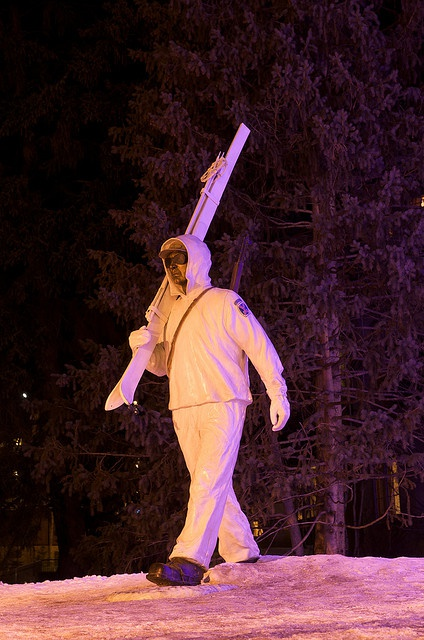Describe the objects in this image and their specific colors. I can see people in black, salmon, tan, and violet tones and skis in black, violet, orange, lightpink, and salmon tones in this image. 